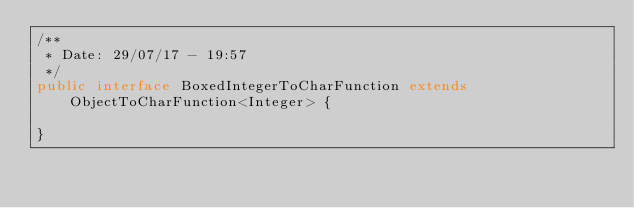Convert code to text. <code><loc_0><loc_0><loc_500><loc_500><_Java_>/**
 * Date: 29/07/17 - 19:57
 */
public interface BoxedIntegerToCharFunction extends ObjectToCharFunction<Integer> {

}
</code> 